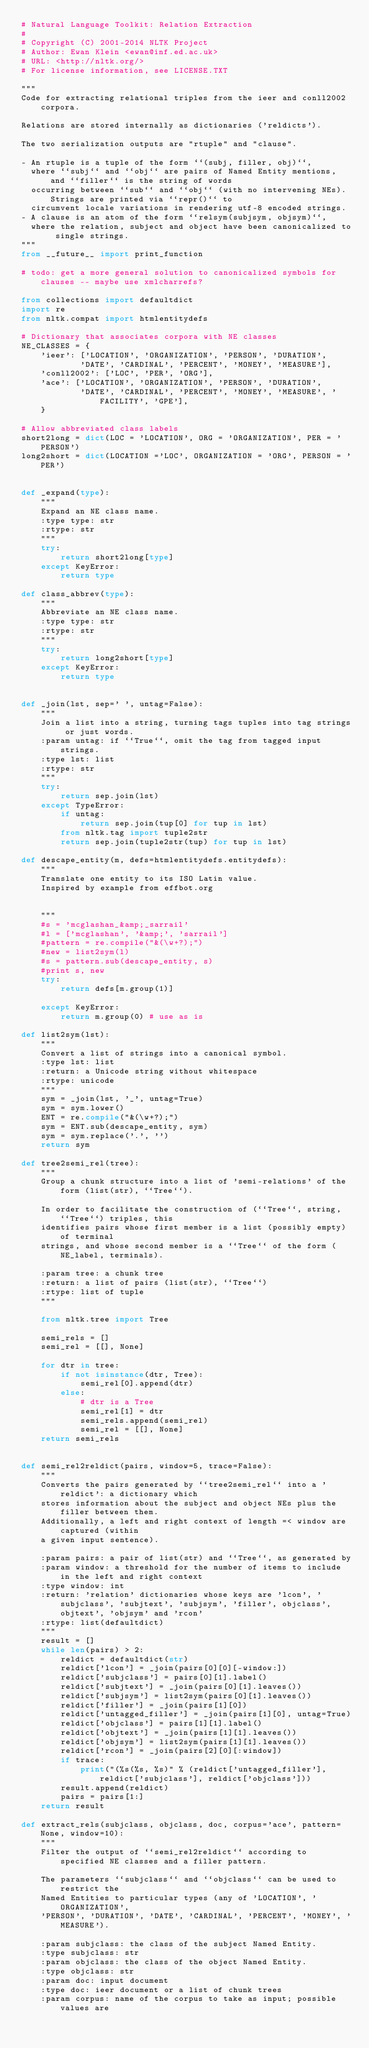Convert code to text. <code><loc_0><loc_0><loc_500><loc_500><_Python_># Natural Language Toolkit: Relation Extraction
#
# Copyright (C) 2001-2014 NLTK Project
# Author: Ewan Klein <ewan@inf.ed.ac.uk>
# URL: <http://nltk.org/>
# For license information, see LICENSE.TXT

"""
Code for extracting relational triples from the ieer and conll2002 corpora.

Relations are stored internally as dictionaries ('reldicts').

The two serialization outputs are "rtuple" and "clause".

- An rtuple is a tuple of the form ``(subj, filler, obj)``,
  where ``subj`` and ``obj`` are pairs of Named Entity mentions, and ``filler`` is the string of words
  occurring between ``sub`` and ``obj`` (with no intervening NEs). Strings are printed via ``repr()`` to
  circumvent locale variations in rendering utf-8 encoded strings.
- A clause is an atom of the form ``relsym(subjsym, objsym)``,
  where the relation, subject and object have been canonicalized to single strings.
"""
from __future__ import print_function

# todo: get a more general solution to canonicalized symbols for clauses -- maybe use xmlcharrefs?

from collections import defaultdict
import re
from nltk.compat import htmlentitydefs

# Dictionary that associates corpora with NE classes
NE_CLASSES = {
    'ieer': ['LOCATION', 'ORGANIZATION', 'PERSON', 'DURATION',
            'DATE', 'CARDINAL', 'PERCENT', 'MONEY', 'MEASURE'],
    'conll2002': ['LOC', 'PER', 'ORG'],
    'ace': ['LOCATION', 'ORGANIZATION', 'PERSON', 'DURATION',
            'DATE', 'CARDINAL', 'PERCENT', 'MONEY', 'MEASURE', 'FACILITY', 'GPE'],
    }

# Allow abbreviated class labels
short2long = dict(LOC = 'LOCATION', ORG = 'ORGANIZATION', PER = 'PERSON')
long2short = dict(LOCATION ='LOC', ORGANIZATION = 'ORG', PERSON = 'PER')


def _expand(type):
    """
    Expand an NE class name.
    :type type: str
    :rtype: str
    """
    try:
        return short2long[type]
    except KeyError:
        return type

def class_abbrev(type):
    """
    Abbreviate an NE class name.
    :type type: str
    :rtype: str
    """
    try:
        return long2short[type]
    except KeyError:
        return type


def _join(lst, sep=' ', untag=False):
    """
    Join a list into a string, turning tags tuples into tag strings or just words.
    :param untag: if ``True``, omit the tag from tagged input strings.
    :type lst: list
    :rtype: str
    """
    try:
        return sep.join(lst)
    except TypeError:
        if untag:
            return sep.join(tup[0] for tup in lst)
        from nltk.tag import tuple2str
        return sep.join(tuple2str(tup) for tup in lst)

def descape_entity(m, defs=htmlentitydefs.entitydefs):
    """
    Translate one entity to its ISO Latin value.
    Inspired by example from effbot.org


    """
    #s = 'mcglashan_&amp;_sarrail'
    #l = ['mcglashan', '&amp;', 'sarrail']
    #pattern = re.compile("&(\w+?);")
    #new = list2sym(l)
    #s = pattern.sub(descape_entity, s)
    #print s, new
    try:
        return defs[m.group(1)]

    except KeyError:
        return m.group(0) # use as is

def list2sym(lst):
    """
    Convert a list of strings into a canonical symbol.
    :type lst: list
    :return: a Unicode string without whitespace
    :rtype: unicode
    """
    sym = _join(lst, '_', untag=True)
    sym = sym.lower()
    ENT = re.compile("&(\w+?);")
    sym = ENT.sub(descape_entity, sym)
    sym = sym.replace('.', '')
    return sym

def tree2semi_rel(tree):
    """
    Group a chunk structure into a list of 'semi-relations' of the form (list(str), ``Tree``). 

    In order to facilitate the construction of (``Tree``, string, ``Tree``) triples, this
    identifies pairs whose first member is a list (possibly empty) of terminal
    strings, and whose second member is a ``Tree`` of the form (NE_label, terminals).

    :param tree: a chunk tree
    :return: a list of pairs (list(str), ``Tree``)
    :rtype: list of tuple
    """

    from nltk.tree import Tree

    semi_rels = []
    semi_rel = [[], None]

    for dtr in tree:
        if not isinstance(dtr, Tree):
            semi_rel[0].append(dtr)
        else:
            # dtr is a Tree
            semi_rel[1] = dtr
            semi_rels.append(semi_rel)
            semi_rel = [[], None]
    return semi_rels


def semi_rel2reldict(pairs, window=5, trace=False):
    """
    Converts the pairs generated by ``tree2semi_rel`` into a 'reldict': a dictionary which
    stores information about the subject and object NEs plus the filler between them.
    Additionally, a left and right context of length =< window are captured (within
    a given input sentence).

    :param pairs: a pair of list(str) and ``Tree``, as generated by
    :param window: a threshold for the number of items to include in the left and right context
    :type window: int
    :return: 'relation' dictionaries whose keys are 'lcon', 'subjclass', 'subjtext', 'subjsym', 'filler', objclass', objtext', 'objsym' and 'rcon'
    :rtype: list(defaultdict)
    """
    result = []
    while len(pairs) > 2:
        reldict = defaultdict(str)
        reldict['lcon'] = _join(pairs[0][0][-window:])
        reldict['subjclass'] = pairs[0][1].label()
        reldict['subjtext'] = _join(pairs[0][1].leaves())
        reldict['subjsym'] = list2sym(pairs[0][1].leaves())
        reldict['filler'] = _join(pairs[1][0])
        reldict['untagged_filler'] = _join(pairs[1][0], untag=True)
        reldict['objclass'] = pairs[1][1].label()
        reldict['objtext'] = _join(pairs[1][1].leaves())
        reldict['objsym'] = list2sym(pairs[1][1].leaves())
        reldict['rcon'] = _join(pairs[2][0][:window])
        if trace:
            print("(%s(%s, %s)" % (reldict['untagged_filler'], reldict['subjclass'], reldict['objclass']))
        result.append(reldict)
        pairs = pairs[1:]
    return result

def extract_rels(subjclass, objclass, doc, corpus='ace', pattern=None, window=10):
    """
    Filter the output of ``semi_rel2reldict`` according to specified NE classes and a filler pattern.

    The parameters ``subjclass`` and ``objclass`` can be used to restrict the
    Named Entities to particular types (any of 'LOCATION', 'ORGANIZATION',
    'PERSON', 'DURATION', 'DATE', 'CARDINAL', 'PERCENT', 'MONEY', 'MEASURE').

    :param subjclass: the class of the subject Named Entity.
    :type subjclass: str
    :param objclass: the class of the object Named Entity.
    :type objclass: str
    :param doc: input document
    :type doc: ieer document or a list of chunk trees
    :param corpus: name of the corpus to take as input; possible values are</code> 